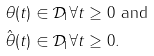Convert formula to latex. <formula><loc_0><loc_0><loc_500><loc_500>\theta ( t ) & \in { \mathcal { D } } _ { 1 } \forall t \geq 0 \text { and} \\ \hat { \theta } ( t ) & \in { \mathcal { D } } _ { 1 } \forall t \geq 0 .</formula> 